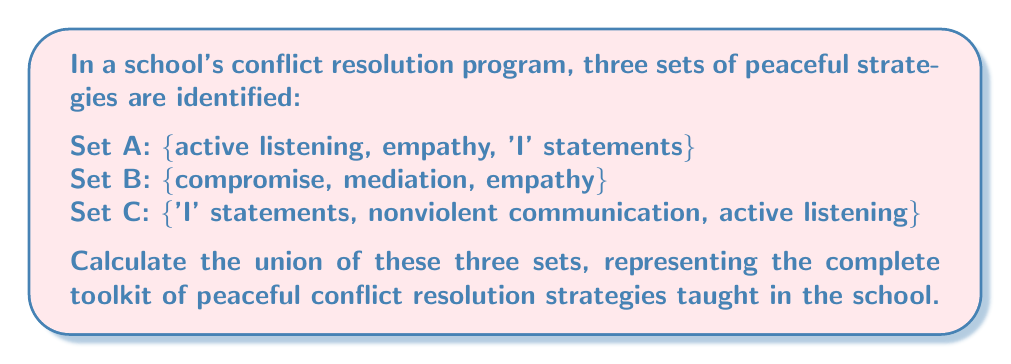Solve this math problem. To find the union of these three sets, we need to combine all unique elements from each set. Let's approach this step-by-step:

1) First, let's write out the mathematical notation for the union of these three sets:
   $$ A \cup B \cup C $$

2) Now, let's list all elements from each set:
   Set A: active listening, empathy, 'I' statements
   Set B: compromise, mediation, empathy
   Set C: 'I' statements, nonviolent communication, active listening

3) To find the union, we include each unique element only once. Let's go through each element:

   - active listening: in A and C
   - empathy: in A and B
   - 'I' statements: in A and C
   - compromise: in B
   - mediation: in B
   - nonviolent communication: in C

4) Therefore, the union of these sets includes all these unique elements:
   $$ A \cup B \cup C = \text{\{active listening, empathy, 'I' statements, compromise, mediation, nonviolent communication\}} $$

5) Count the number of elements in the union:
   $$ |A \cup B \cup C| = 6 $$

This union represents the complete toolkit of peaceful conflict resolution strategies taught in the school, combining all unique approaches from the three original sets.
Answer: $$ A \cup B \cup C = \text{\{active listening, empathy, 'I' statements, compromise, mediation, nonviolent communication\}} $$
The union contains 6 elements. 